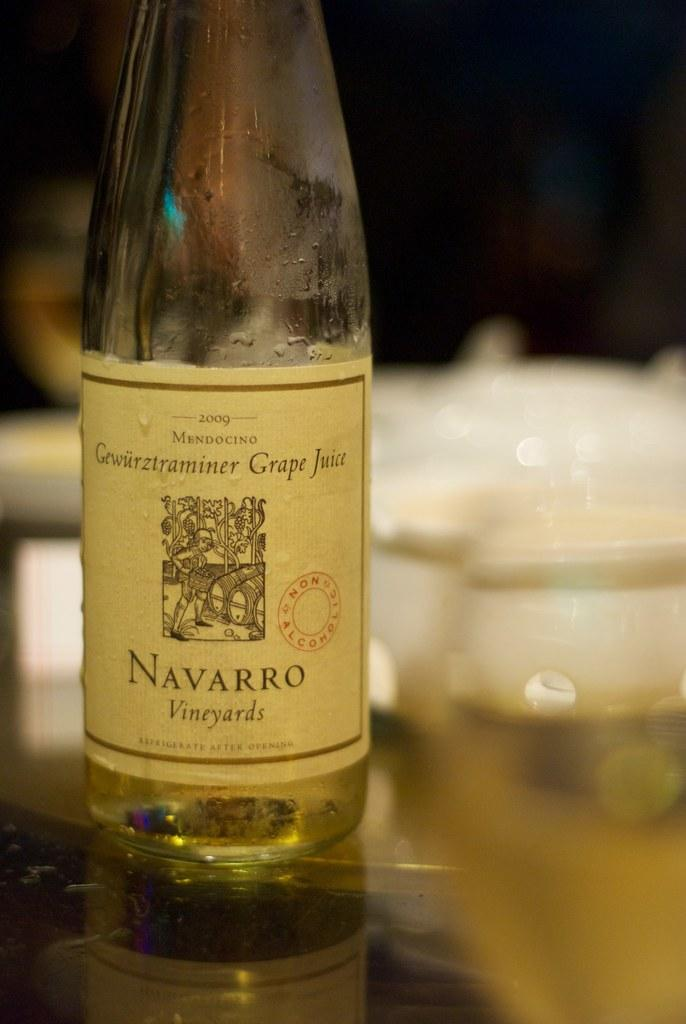<image>
Write a terse but informative summary of the picture. A bottle of wine on a table that is from Navarro Vineyards. 